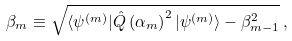<formula> <loc_0><loc_0><loc_500><loc_500>\beta _ { m } \equiv \sqrt { \langle \psi ^ { ( m ) } | \hat { Q } \left ( \alpha _ { m } \right ) ^ { 2 } | \psi ^ { ( m ) } \rangle - \beta _ { m - 1 } ^ { 2 } } \, ,</formula> 